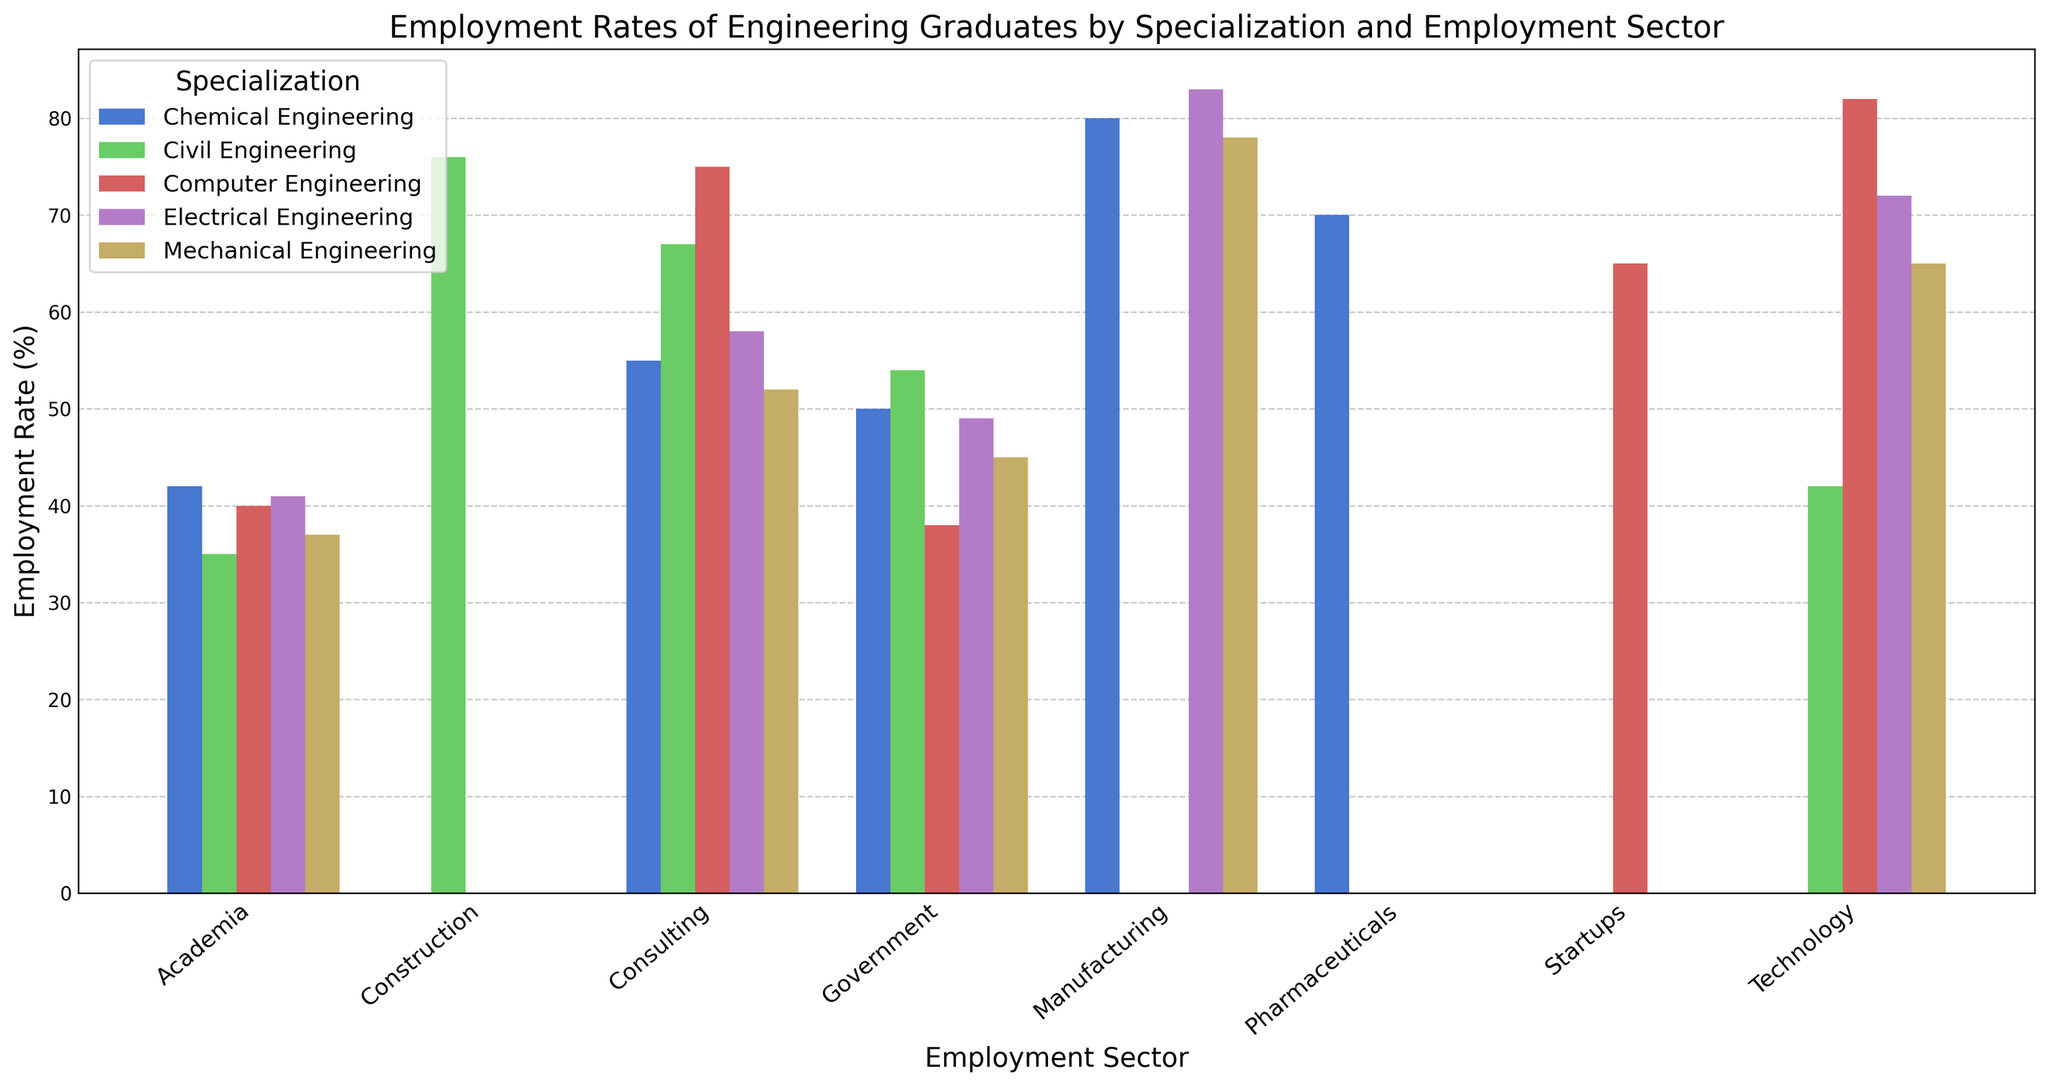Which specialization has the highest employment rate in the Technology sector? Identify the Technology sector and compare the heights of the bars for each specialization. The tallest bar represents the highest employment rate.
Answer: Electrical Engineering Which employment sector shows the lowest employment rate for Civil Engineering graduates? Locate the bars corresponding to Civil Engineering graduates and identify the shortest bar among them. The sector for this bar is the answer.
Answer: Academia Are there more sectors where Employment Rate exceeds 70% for Electrical Engineering or for Computer Engineering? Identify the sectors with a bar height exceeding 70% for both specializations and count them. Compare the counts to determine which specialization has more sectors.
Answer: Electrical Engineering What is the difference in employment rates between Mechanical Engineering and Chemical Engineering in the Manufacturing sector? Find the heights of the bars for Mechanical Engineering and Chemical Engineering in the Manufacturing sector and subtract the smaller value from the larger value (80 - 78).
Answer: 2% Which specialization has the most consistent employment rates across different sectors? Compare the variation in bar heights for each specialization. The specialization with the least variation in height is the most consistent.
Answer: Civil Engineering What is the average employment rate for Computer Engineering graduates in Consulting and Startups sectors? Add the employment rates for Computer Engineering in Consulting and Startups sectors and divide by 2 ((75 + 65) / 2).
Answer: 70% Which specialization has the lowest employment rate in the Government sector? Find the bars representing the Government sector and identify the shortest one.
Answer: Mechanical Engineering What is the sum of the employment rates for Civil Engineering in the Consulting, Technology, and Academia sectors? Add the employment rates for Civil Engineering in Consulting, Technology, and Academia (67 + 42 + 35).
Answer: 144 Compare the employment rates of Electrical Engineering and Computer Engineering in the Academia sector. Which one is higher? Identify the bar heights of Electrical Engineering and Computer Engineering in the Academia sector and compare them.
Answer: Electrical Engineering For which specialization does the Manufacturing sector have the highest employment rate? Identify the Manufacturing sector and compare the bar heights for each specialization. Locate the highest bar.
Answer: Electrical Engineering 